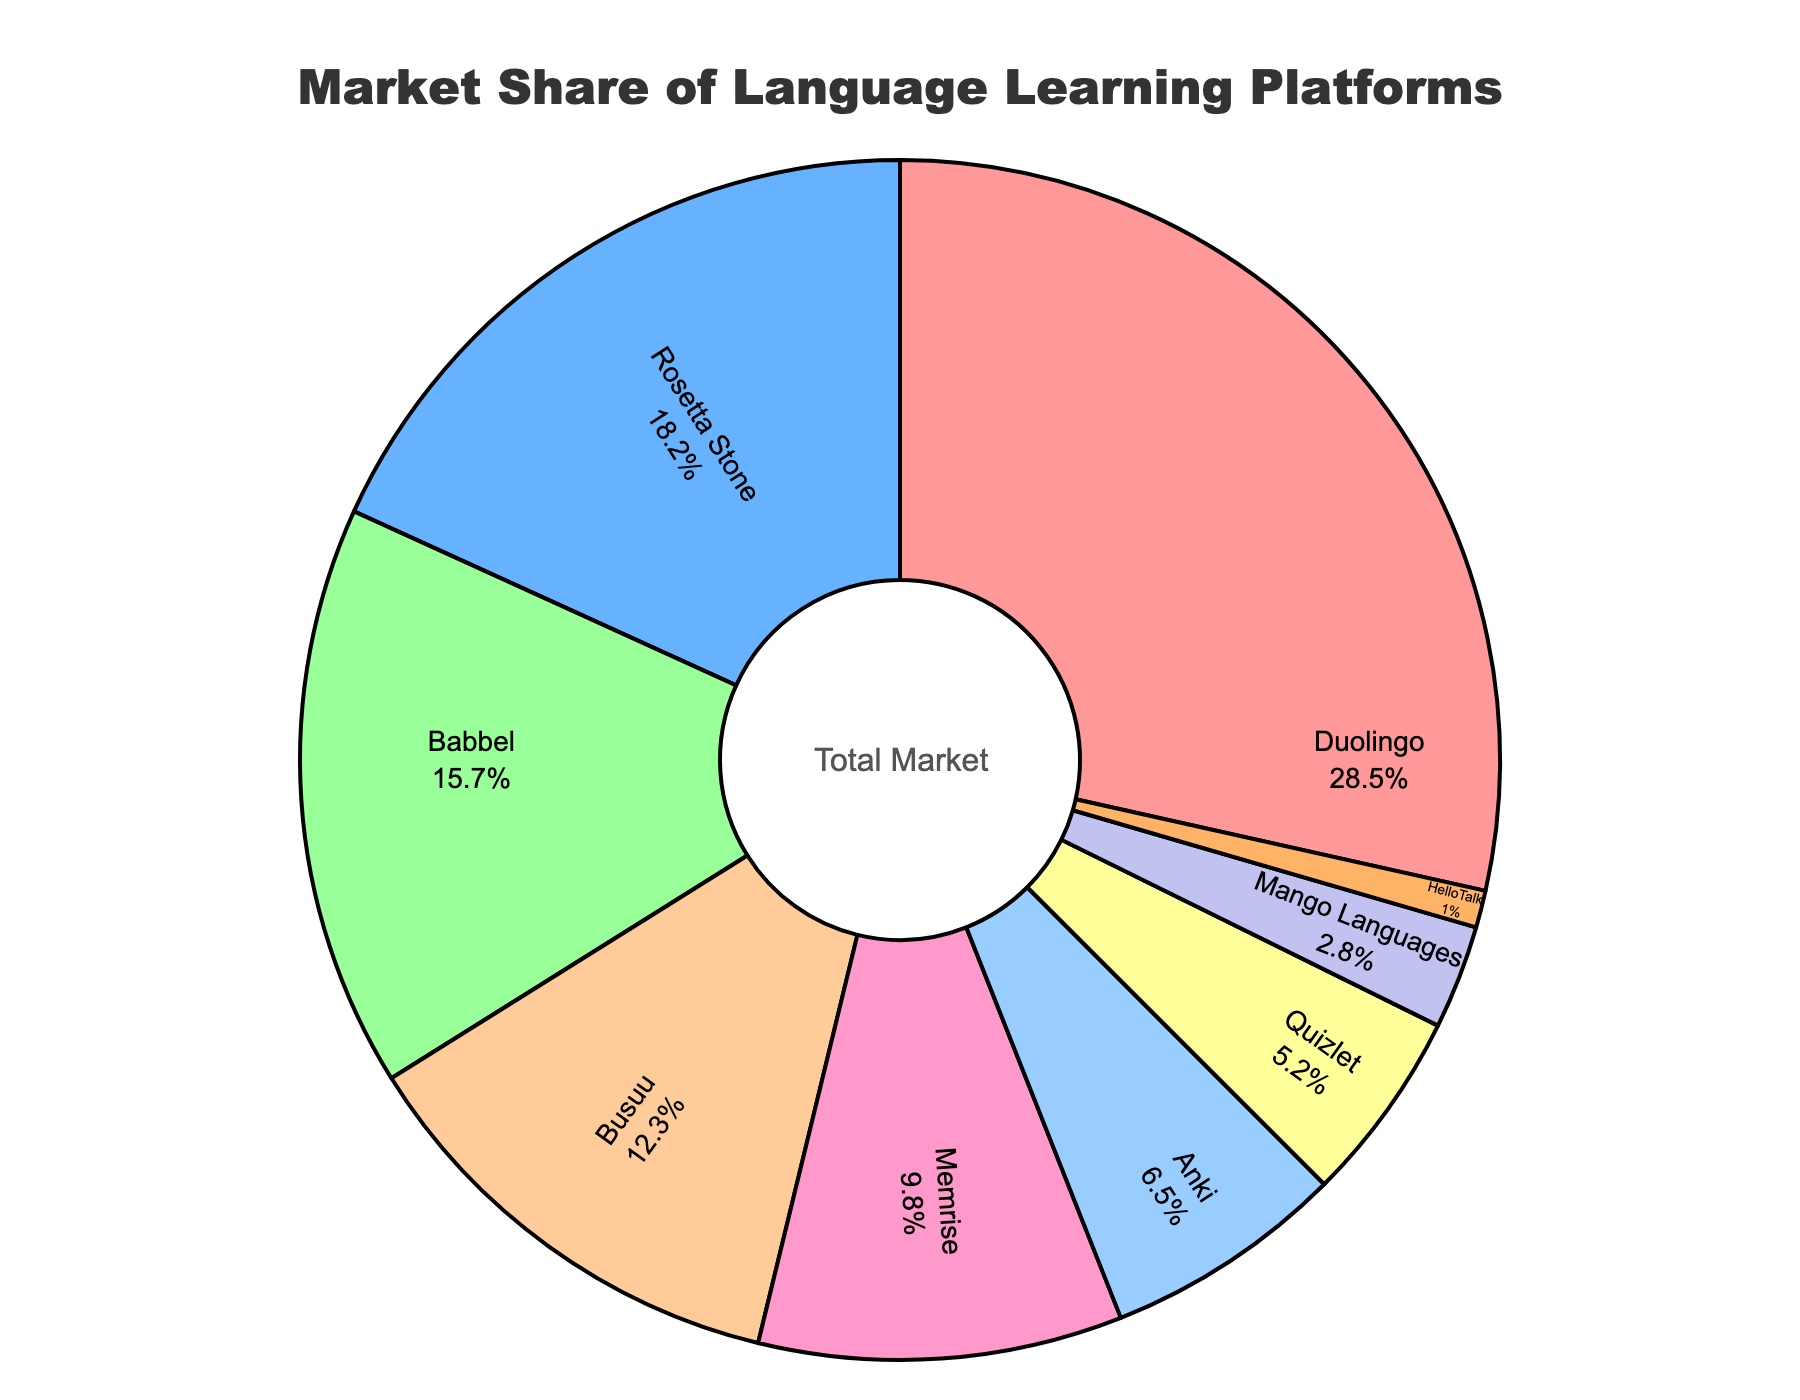What platform has the highest market share? The figure shows the percentage of market share for each platform. Duolingo has the highest single percentage.
Answer: Duolingo Which platform has the second largest market share? The figure shows the percentage of market share for each platform. After Duolingo, Rosetta Stone has the next highest percentage.
Answer: Rosetta Stone How much more market share does Duolingo have compared to Quizlet? Duolingo has 28.5% of the market while Quizlet has 5.2%. The difference is 28.5% - 5.2%.
Answer: 23.3% What is the combined market share of Babbel and Memrise? The figure shows Babbel with 15.7% and Memrise with 9.8%. Adding these together gives 15.7% + 9.8%.
Answer: 25.5% Which platforms have a market share lower than 10%? From the figure, Memrise (9.8%), Anki (6.5%), Quizlet (5.2%), Mango Languages (2.8%), and HelloTalk (1.0%) are below 10%.
Answer: Memrise, Anki, Quizlet, Mango Languages, HelloTalk How much market share is held by platforms other than Duolingo and Rosetta Stone? The combined market share is 100%. Subtracting the shares of Duolingo (28.5%) and Rosetta Stone (18.2%) gives 100% - 28.5% - 18.2%.
Answer: 53.3% What is the average market share of the bottom three platforms? The bottom three platforms are Mango Languages (2.8%), HelloTalk (1.0%), and Quizlet (5.2%). The average is (2.8% + 1.0% + 5.2%) / 3.
Answer: 3.0% Which platform has the smallest market share and what is its percentage? The figure shows the smallest market share is held by HelloTalk with a label inside the pie.
Answer: HelloTalk, 1.0% Rank the platforms in descending order of their market share percentages. From the figure, the percentages can be ranked as follows: Duolingo, Rosetta Stone, Babbel, Busuu, Memrise, Anki, Quizlet, Mango Languages, HelloTalk.
Answer: Duolingo, Rosetta Stone, Babbel, Busuu, Memrise, Anki, Quizlet, Mango Languages, HelloTalk 